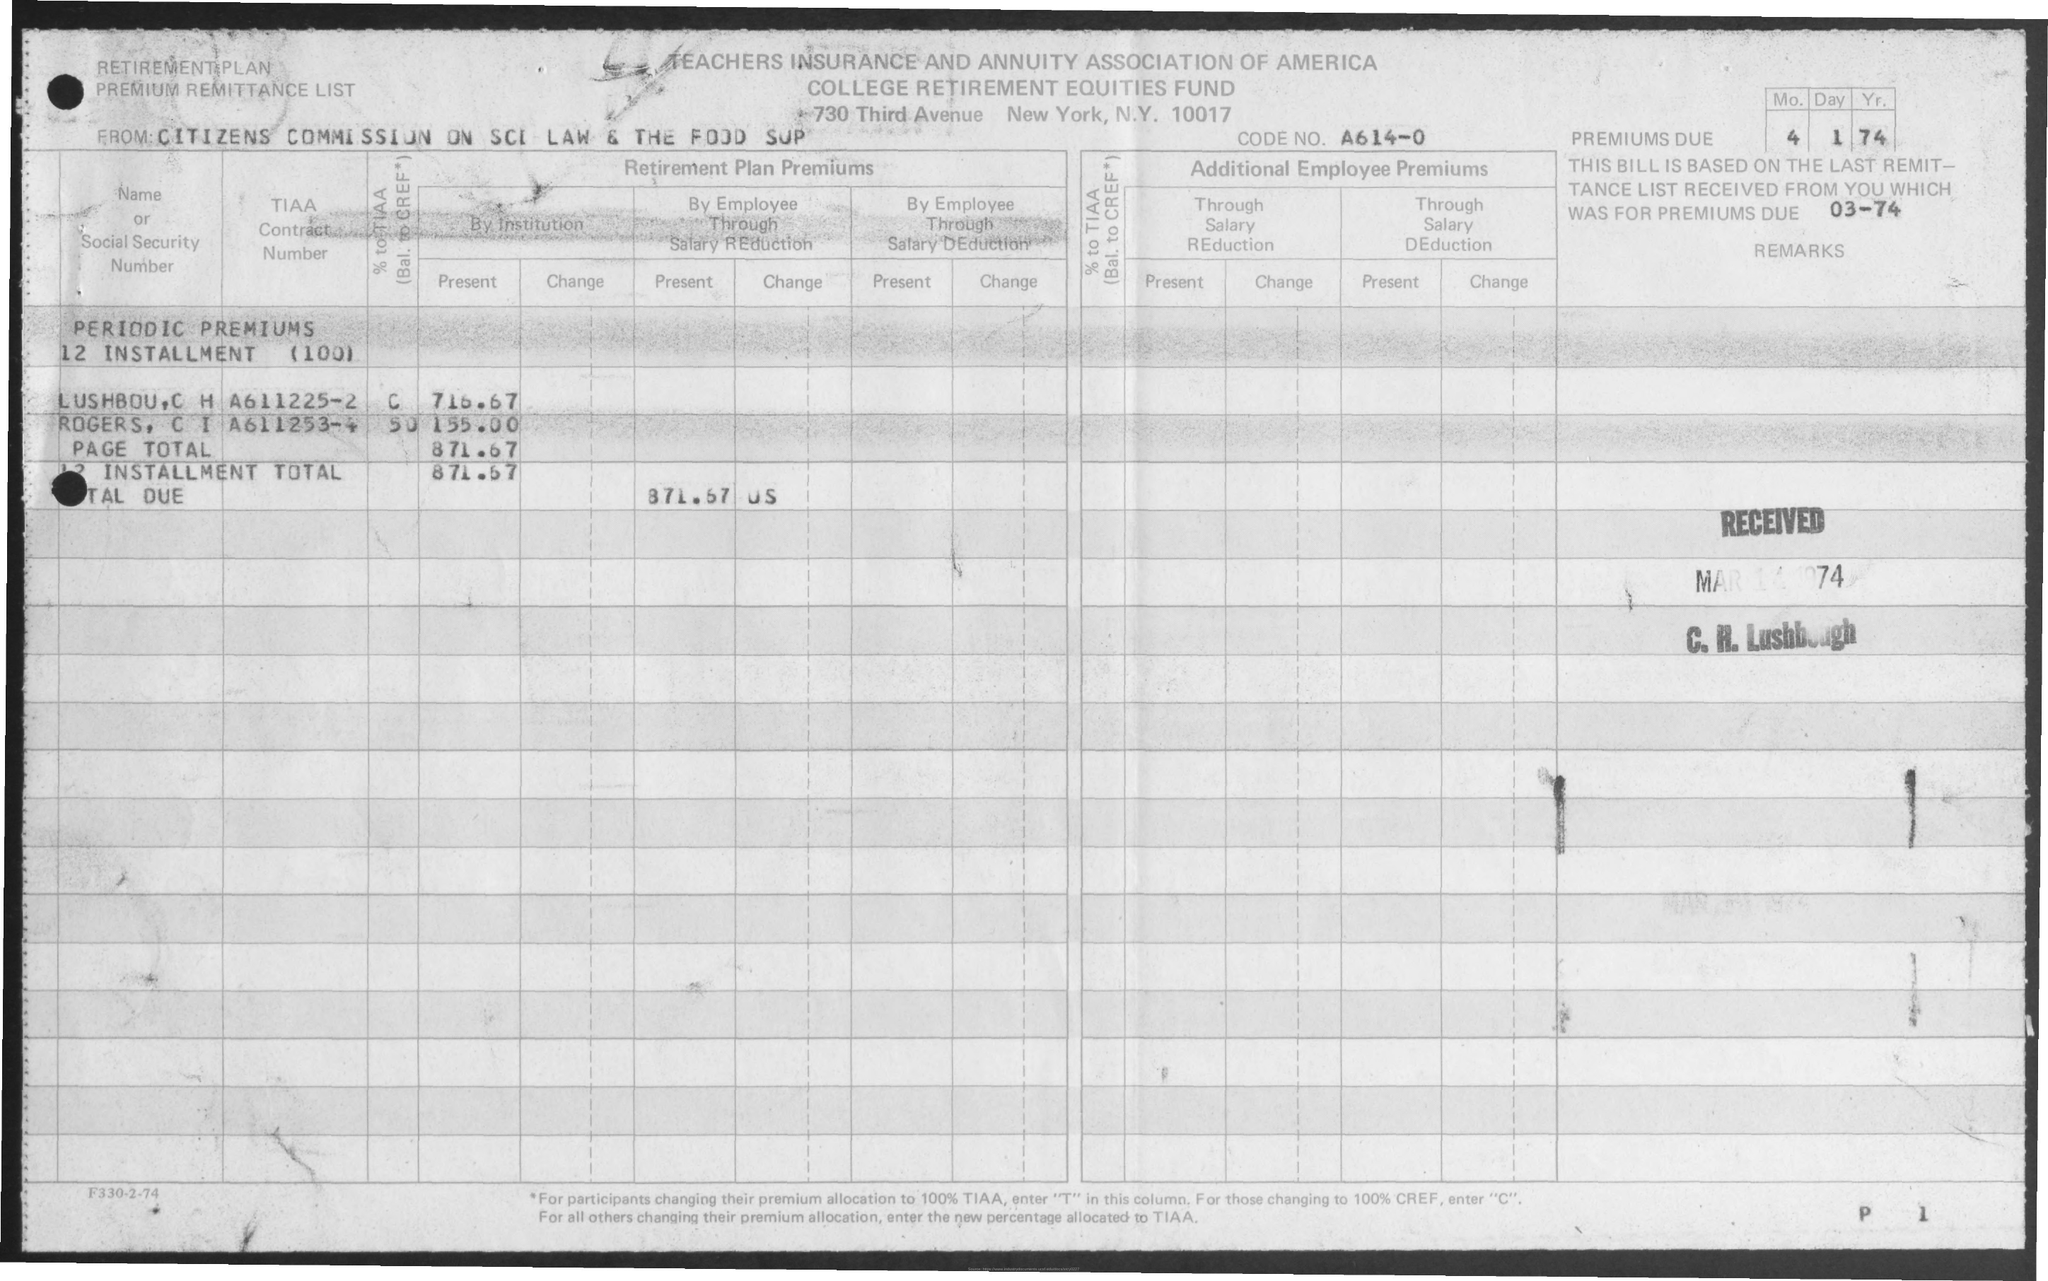From whom is the form?
Ensure brevity in your answer.  CITIZENS COMMISSION ON SCI LAW & THE FOOD SUP. What is the CODE NO.?
Give a very brief answer. A614-0. When is the premiums due?
Your answer should be very brief. 4.1.74. 